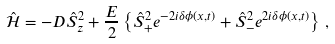Convert formula to latex. <formula><loc_0><loc_0><loc_500><loc_500>\hat { \mathcal { H } } = - D \hat { S } _ { z } ^ { 2 } + \frac { E } { 2 } \left \{ \hat { S } _ { + } ^ { 2 } e ^ { - 2 i \delta \phi ( x , t ) } + \hat { S } _ { - } ^ { 2 } e ^ { 2 i \delta \phi ( x , t ) } \right \} \, ,</formula> 